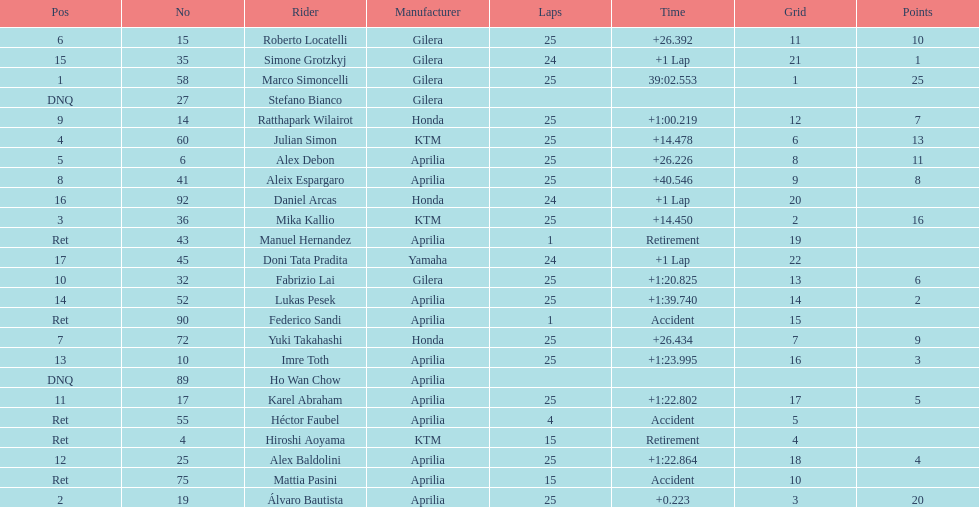The next rider from italy aside from winner marco simoncelli was Roberto Locatelli. 